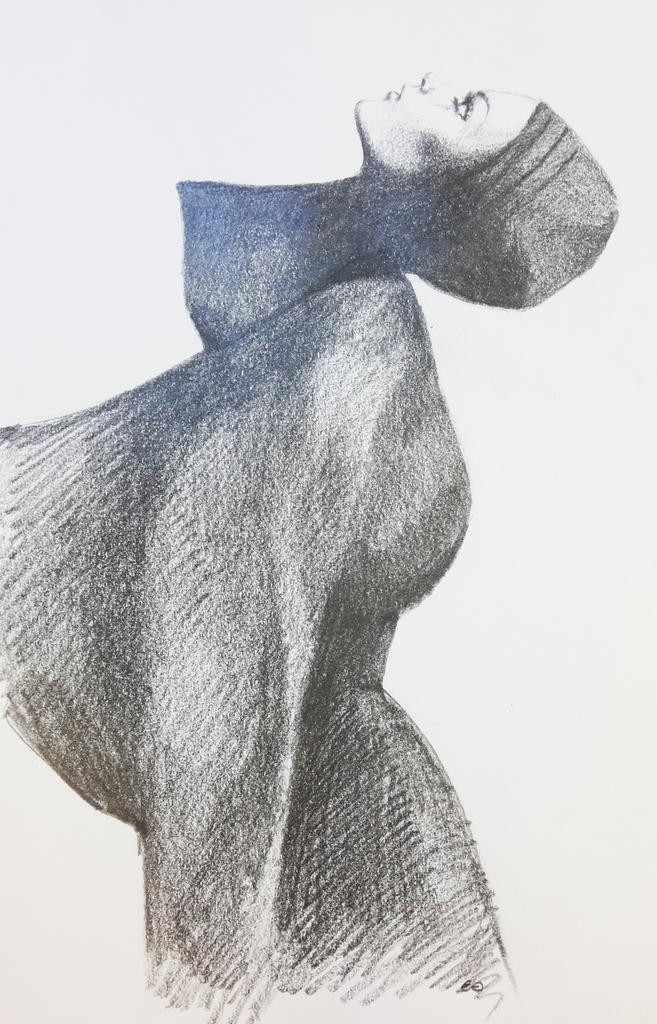What is the main subject of the art piece in the image? The image contains an art piece of a woman. What color is the background of the art piece? The background of the art piece is white. What type of worm can be seen crawling on the woman's hair in the image? There is no worm present in the image; the art piece features a woman with a white background. 